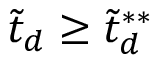Convert formula to latex. <formula><loc_0><loc_0><loc_500><loc_500>\tilde { t } _ { d } \geq \tilde { t } _ { d } ^ { * * }</formula> 